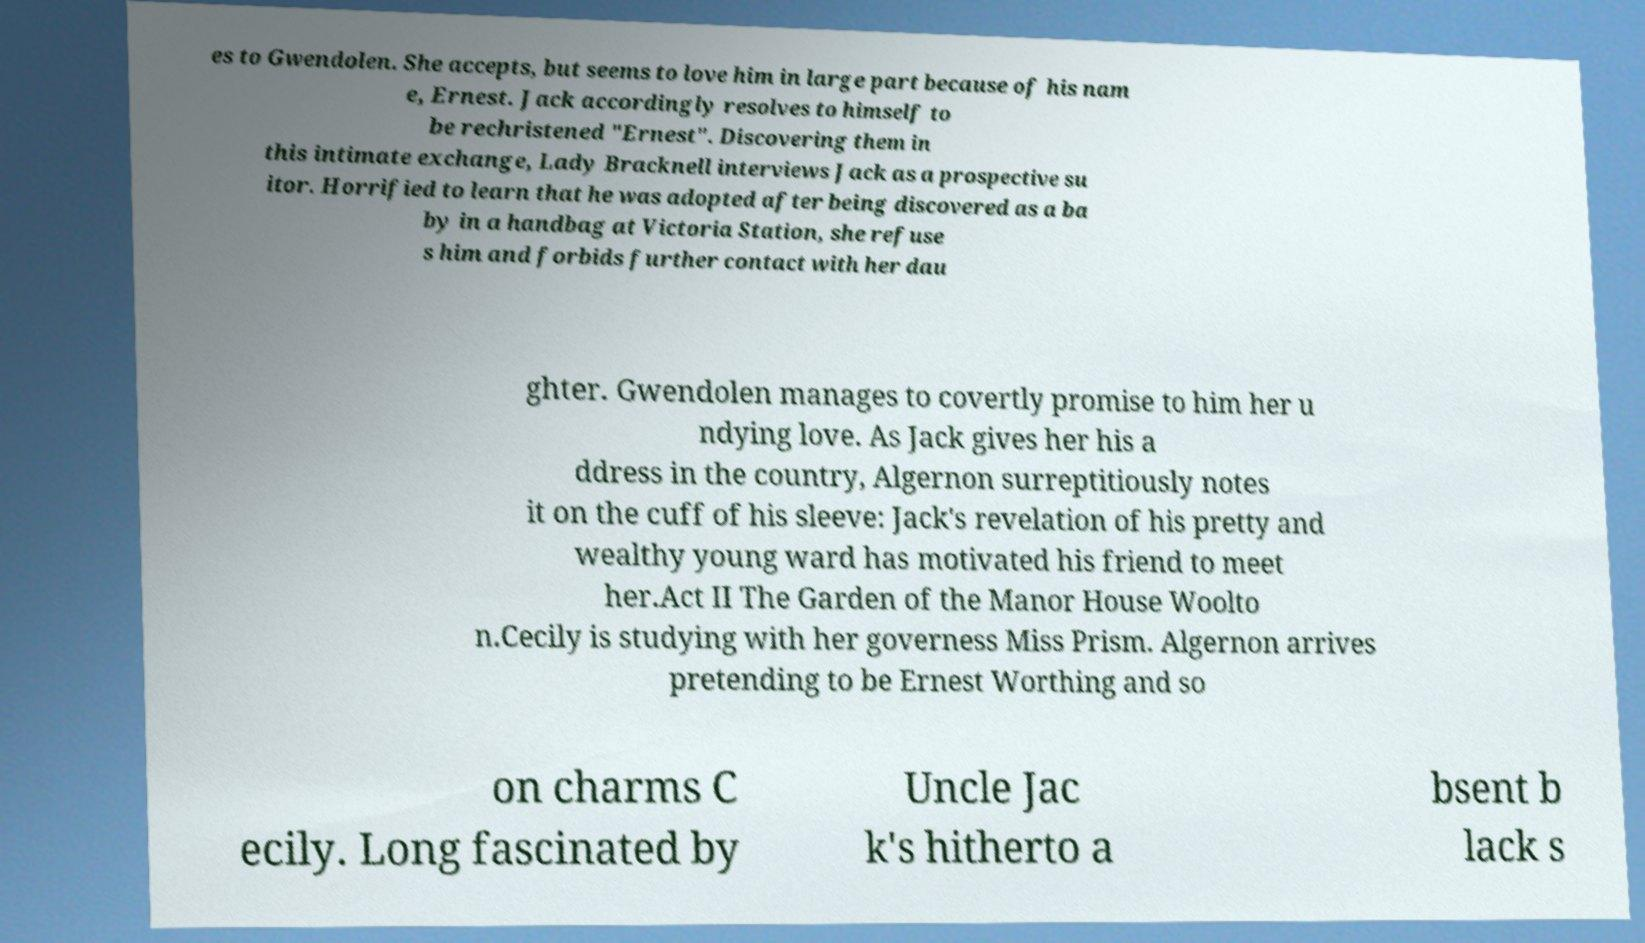Can you accurately transcribe the text from the provided image for me? es to Gwendolen. She accepts, but seems to love him in large part because of his nam e, Ernest. Jack accordingly resolves to himself to be rechristened "Ernest". Discovering them in this intimate exchange, Lady Bracknell interviews Jack as a prospective su itor. Horrified to learn that he was adopted after being discovered as a ba by in a handbag at Victoria Station, she refuse s him and forbids further contact with her dau ghter. Gwendolen manages to covertly promise to him her u ndying love. As Jack gives her his a ddress in the country, Algernon surreptitiously notes it on the cuff of his sleeve: Jack's revelation of his pretty and wealthy young ward has motivated his friend to meet her.Act II The Garden of the Manor House Woolto n.Cecily is studying with her governess Miss Prism. Algernon arrives pretending to be Ernest Worthing and so on charms C ecily. Long fascinated by Uncle Jac k's hitherto a bsent b lack s 